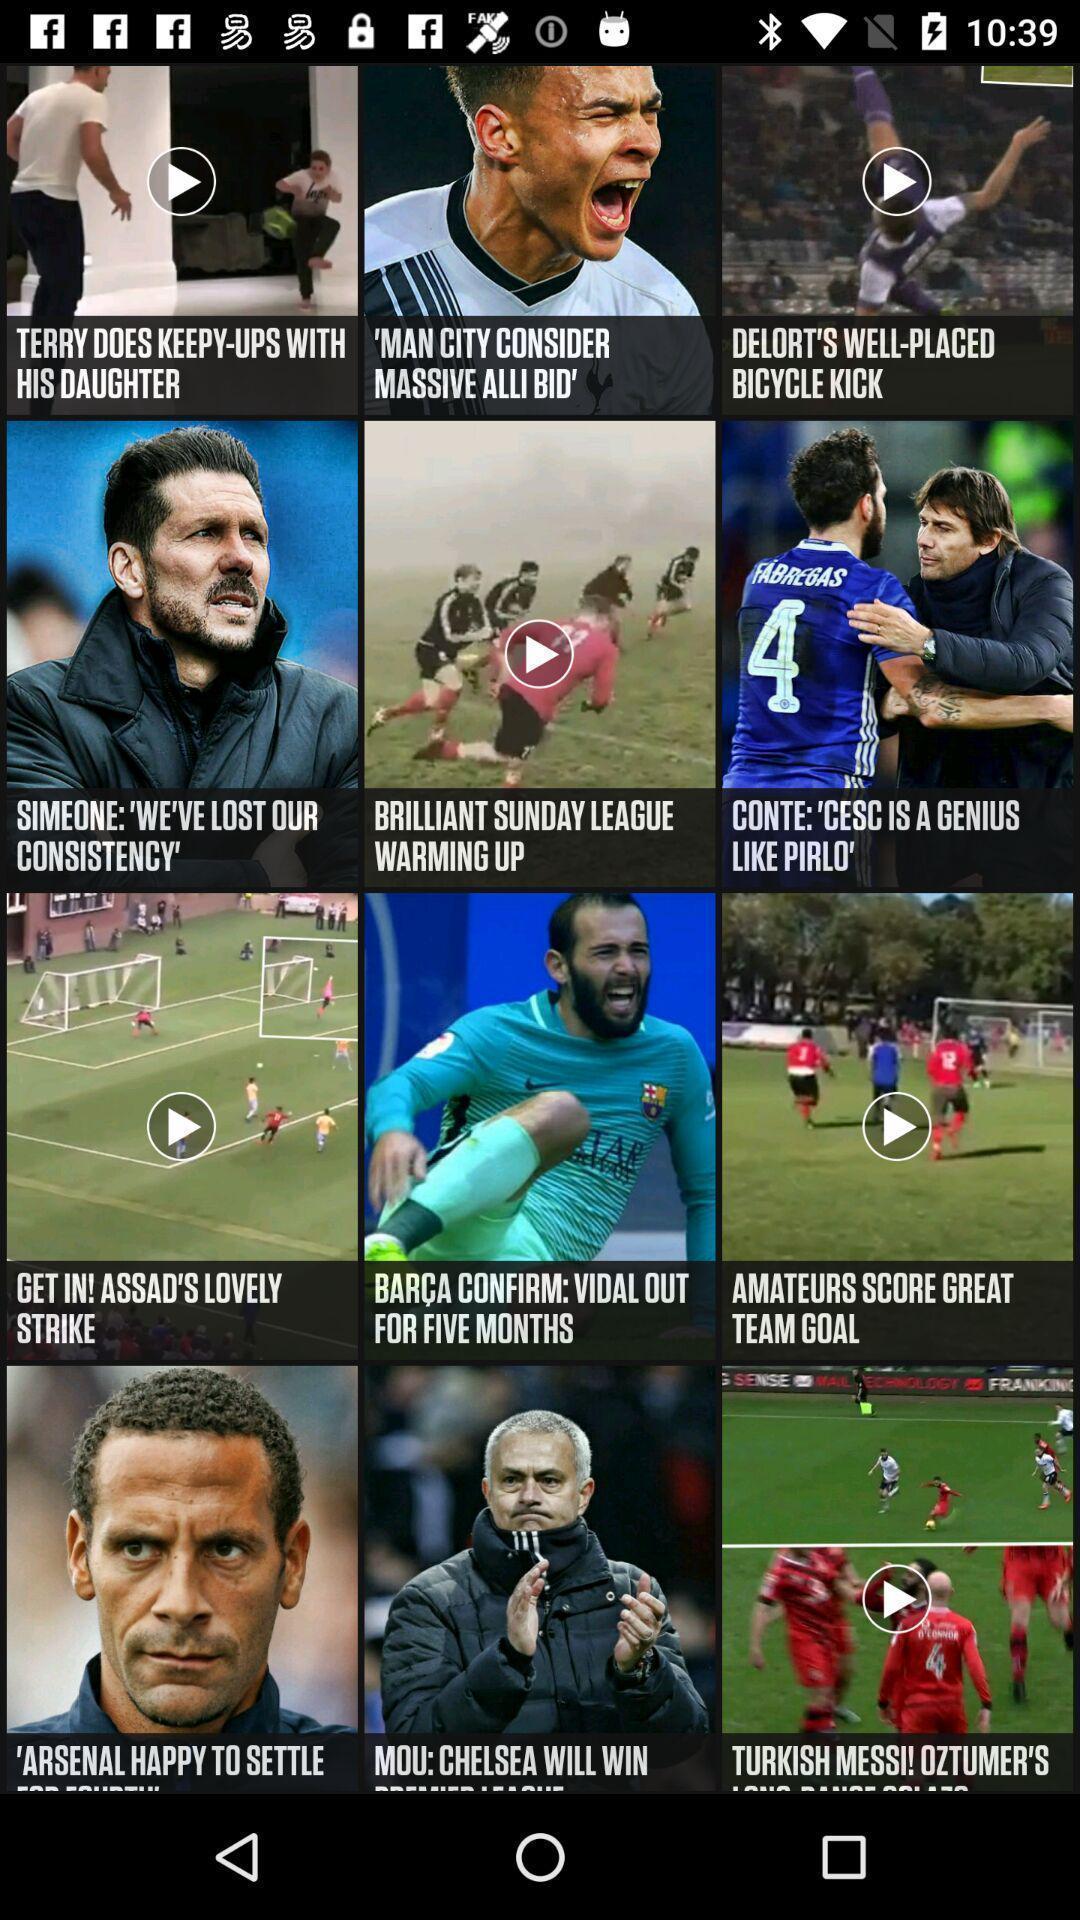Summarize the main components in this picture. Various feed and articles displayed of a sports app. 